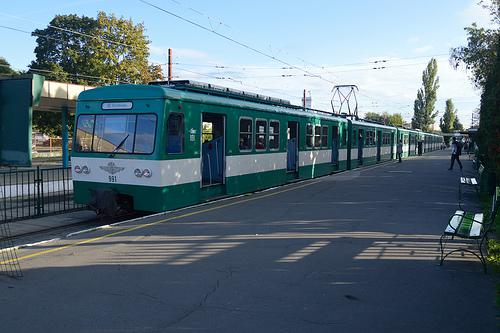Question: when will the train leave the platform?
Choices:
A. It's scheduled time.
B. When it meets capacity.
C. When the train in front moves.
D. After the passengers have entered.
Answer with the letter. Answer: D Question: what color is the train?
Choices:
A. Orange and white.
B. Green and orange.
C. Blue and pink.
D. Green and white.
Answer with the letter. Answer: D Question: where is this picture located?
Choices:
A. At the airport.
B. At the zoo.
C. At a train station.
D. At the beach.
Answer with the letter. Answer: C 